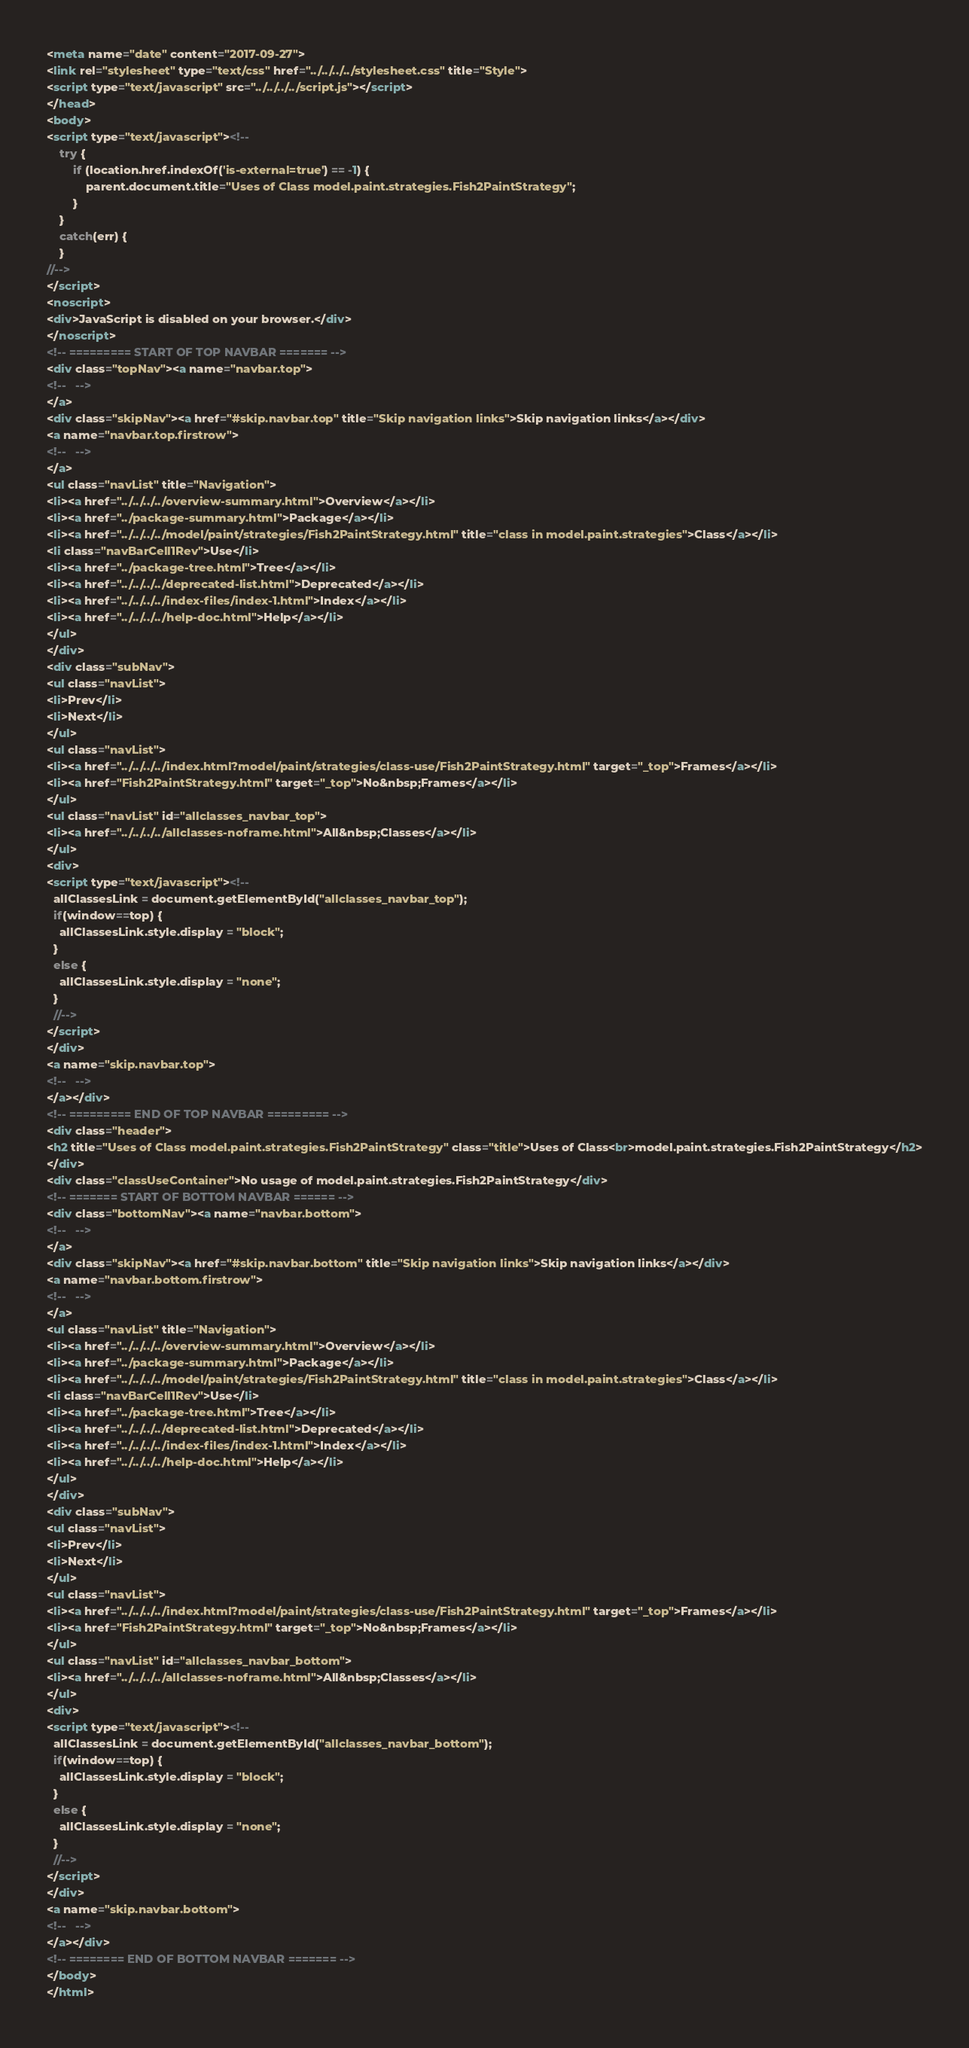<code> <loc_0><loc_0><loc_500><loc_500><_HTML_><meta name="date" content="2017-09-27">
<link rel="stylesheet" type="text/css" href="../../../../stylesheet.css" title="Style">
<script type="text/javascript" src="../../../../script.js"></script>
</head>
<body>
<script type="text/javascript"><!--
    try {
        if (location.href.indexOf('is-external=true') == -1) {
            parent.document.title="Uses of Class model.paint.strategies.Fish2PaintStrategy";
        }
    }
    catch(err) {
    }
//-->
</script>
<noscript>
<div>JavaScript is disabled on your browser.</div>
</noscript>
<!-- ========= START OF TOP NAVBAR ======= -->
<div class="topNav"><a name="navbar.top">
<!--   -->
</a>
<div class="skipNav"><a href="#skip.navbar.top" title="Skip navigation links">Skip navigation links</a></div>
<a name="navbar.top.firstrow">
<!--   -->
</a>
<ul class="navList" title="Navigation">
<li><a href="../../../../overview-summary.html">Overview</a></li>
<li><a href="../package-summary.html">Package</a></li>
<li><a href="../../../../model/paint/strategies/Fish2PaintStrategy.html" title="class in model.paint.strategies">Class</a></li>
<li class="navBarCell1Rev">Use</li>
<li><a href="../package-tree.html">Tree</a></li>
<li><a href="../../../../deprecated-list.html">Deprecated</a></li>
<li><a href="../../../../index-files/index-1.html">Index</a></li>
<li><a href="../../../../help-doc.html">Help</a></li>
</ul>
</div>
<div class="subNav">
<ul class="navList">
<li>Prev</li>
<li>Next</li>
</ul>
<ul class="navList">
<li><a href="../../../../index.html?model/paint/strategies/class-use/Fish2PaintStrategy.html" target="_top">Frames</a></li>
<li><a href="Fish2PaintStrategy.html" target="_top">No&nbsp;Frames</a></li>
</ul>
<ul class="navList" id="allclasses_navbar_top">
<li><a href="../../../../allclasses-noframe.html">All&nbsp;Classes</a></li>
</ul>
<div>
<script type="text/javascript"><!--
  allClassesLink = document.getElementById("allclasses_navbar_top");
  if(window==top) {
    allClassesLink.style.display = "block";
  }
  else {
    allClassesLink.style.display = "none";
  }
  //-->
</script>
</div>
<a name="skip.navbar.top">
<!--   -->
</a></div>
<!-- ========= END OF TOP NAVBAR ========= -->
<div class="header">
<h2 title="Uses of Class model.paint.strategies.Fish2PaintStrategy" class="title">Uses of Class<br>model.paint.strategies.Fish2PaintStrategy</h2>
</div>
<div class="classUseContainer">No usage of model.paint.strategies.Fish2PaintStrategy</div>
<!-- ======= START OF BOTTOM NAVBAR ====== -->
<div class="bottomNav"><a name="navbar.bottom">
<!--   -->
</a>
<div class="skipNav"><a href="#skip.navbar.bottom" title="Skip navigation links">Skip navigation links</a></div>
<a name="navbar.bottom.firstrow">
<!--   -->
</a>
<ul class="navList" title="Navigation">
<li><a href="../../../../overview-summary.html">Overview</a></li>
<li><a href="../package-summary.html">Package</a></li>
<li><a href="../../../../model/paint/strategies/Fish2PaintStrategy.html" title="class in model.paint.strategies">Class</a></li>
<li class="navBarCell1Rev">Use</li>
<li><a href="../package-tree.html">Tree</a></li>
<li><a href="../../../../deprecated-list.html">Deprecated</a></li>
<li><a href="../../../../index-files/index-1.html">Index</a></li>
<li><a href="../../../../help-doc.html">Help</a></li>
</ul>
</div>
<div class="subNav">
<ul class="navList">
<li>Prev</li>
<li>Next</li>
</ul>
<ul class="navList">
<li><a href="../../../../index.html?model/paint/strategies/class-use/Fish2PaintStrategy.html" target="_top">Frames</a></li>
<li><a href="Fish2PaintStrategy.html" target="_top">No&nbsp;Frames</a></li>
</ul>
<ul class="navList" id="allclasses_navbar_bottom">
<li><a href="../../../../allclasses-noframe.html">All&nbsp;Classes</a></li>
</ul>
<div>
<script type="text/javascript"><!--
  allClassesLink = document.getElementById("allclasses_navbar_bottom");
  if(window==top) {
    allClassesLink.style.display = "block";
  }
  else {
    allClassesLink.style.display = "none";
  }
  //-->
</script>
</div>
<a name="skip.navbar.bottom">
<!--   -->
</a></div>
<!-- ======== END OF BOTTOM NAVBAR ======= -->
</body>
</html>
</code> 